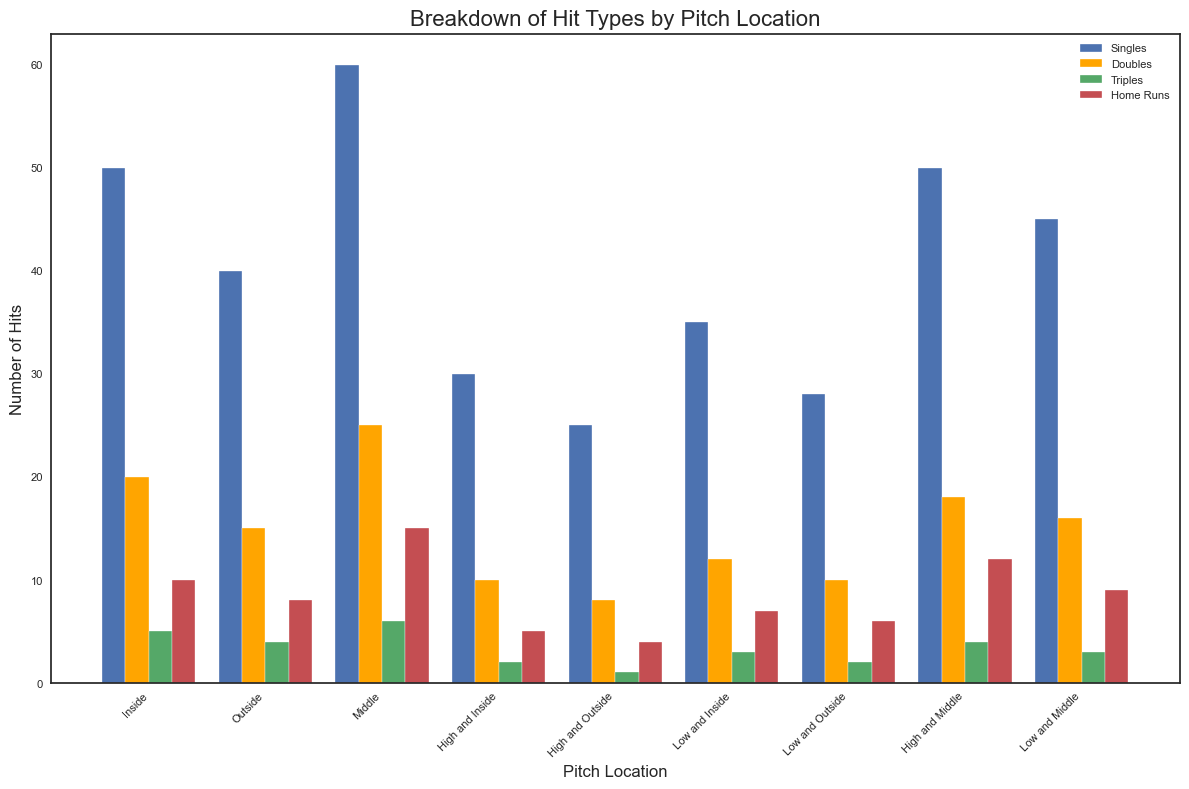What pitch location has the most singles? Look at the bar colors and height that represent singles for each pitch location. The tallest blue bar is for the pitch location "Middle."
Answer: Middle Which hit type has the highest frequency for the "High and Middle" pitch location? Examine the bars at the "High and Middle" tick mark. The red bar representing home runs is the tallest.
Answer: Home Runs How many more doubles are hit from "Middle" compared to "Outside"? Locate and compare the orange bar heights at the "Middle" and "Outside" tick marks. The difference is 25 (Middle) - 15 (Outside) = 10.
Answer: 10 Which pitch location has the fewest triples? Find the shortest green bar point. The "High and Outside" pitch location has the shortest green bar.
Answer: High and Outside What is the total number of hits from the "Low and Middle" pitch location? Sum the bar heights for "Low and Middle": Singles (45) + Doubles (16) + Triples (3) + Home Runs (9) = 73.
Answer: 73 Compare the number of home runs hit from "Inside" and "High and Inside." Which location has more? Compare the red bar heights for "Inside" and "High and Inside." "Inside" has taller red bars than "High and Inside": 10 > 5.
Answer: Inside Which pitch location has the highest total number of home runs? Look at the heights of all the red bars and note which is the tallest. "Middle" has the tallest red bar at 15.
Answer: Middle Is the number of singles more from "Low and Outside" or "High and Outside" pitch locations? Compare the blue bar heights for "Low and Outside" and "High and Outside." "Low and Outside" is higher at 28 than "High and Outside" at 25.
Answer: Low and Outside What's the difference in the total number of hits between "Inside" and "Outside" pitch locations? Calculate total hits for both locations: Inside (50+20+5+10=85) and Outside (40+15+4+8=67). The difference is 85 - 67 = 18.
Answer: 18 What pitch location has an exactly equal number of doubles and home runs? Check pitch locations where the orange and red bar heights are equal. At "Low and Outside," both orange and red bars are equal at 10.
Answer: Low and Outside 